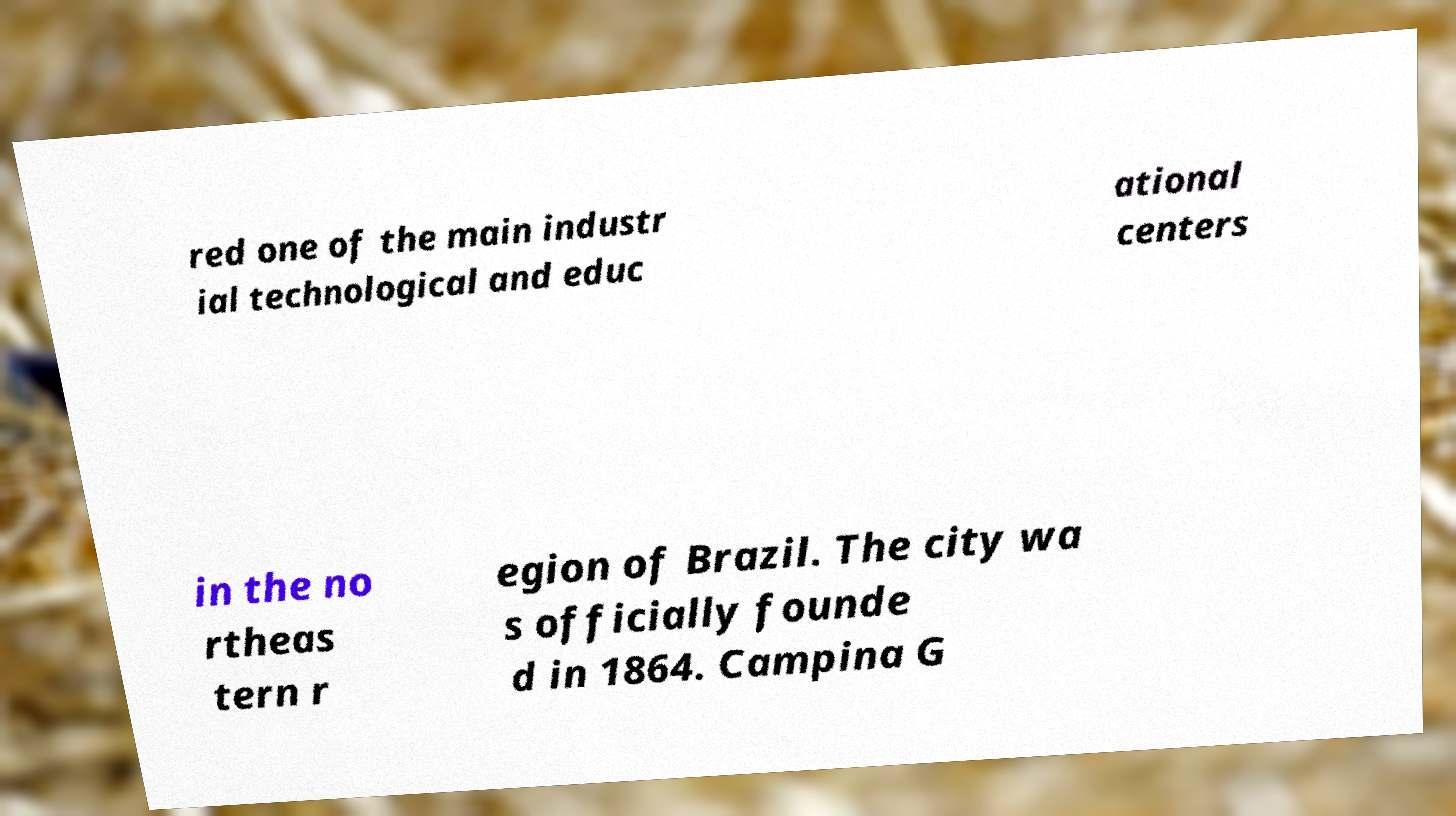Can you read and provide the text displayed in the image?This photo seems to have some interesting text. Can you extract and type it out for me? red one of the main industr ial technological and educ ational centers in the no rtheas tern r egion of Brazil. The city wa s officially founde d in 1864. Campina G 